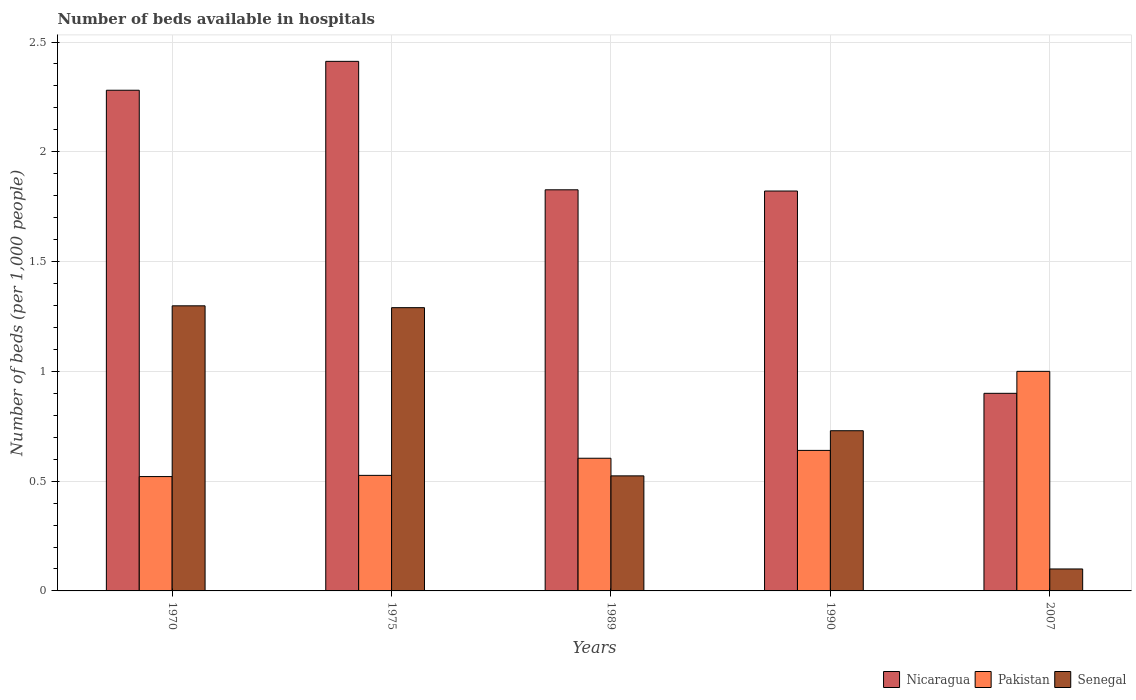How many different coloured bars are there?
Make the answer very short. 3. How many groups of bars are there?
Provide a succinct answer. 5. Are the number of bars per tick equal to the number of legend labels?
Offer a very short reply. Yes. What is the label of the 1st group of bars from the left?
Make the answer very short. 1970. In how many cases, is the number of bars for a given year not equal to the number of legend labels?
Keep it short and to the point. 0. What is the number of beds in the hospiatls of in Pakistan in 1989?
Offer a very short reply. 0.6. Across all years, what is the maximum number of beds in the hospiatls of in Senegal?
Offer a very short reply. 1.3. Across all years, what is the minimum number of beds in the hospiatls of in Senegal?
Provide a short and direct response. 0.1. In which year was the number of beds in the hospiatls of in Nicaragua maximum?
Offer a very short reply. 1975. In which year was the number of beds in the hospiatls of in Nicaragua minimum?
Keep it short and to the point. 2007. What is the total number of beds in the hospiatls of in Nicaragua in the graph?
Your response must be concise. 9.24. What is the difference between the number of beds in the hospiatls of in Pakistan in 1970 and that in 2007?
Offer a very short reply. -0.48. What is the difference between the number of beds in the hospiatls of in Pakistan in 1975 and the number of beds in the hospiatls of in Senegal in 1970?
Provide a succinct answer. -0.77. What is the average number of beds in the hospiatls of in Senegal per year?
Provide a short and direct response. 0.79. In the year 1970, what is the difference between the number of beds in the hospiatls of in Senegal and number of beds in the hospiatls of in Nicaragua?
Give a very brief answer. -0.98. In how many years, is the number of beds in the hospiatls of in Pakistan greater than 2?
Give a very brief answer. 0. What is the ratio of the number of beds in the hospiatls of in Pakistan in 1970 to that in 1989?
Keep it short and to the point. 0.86. Is the number of beds in the hospiatls of in Senegal in 1970 less than that in 1990?
Offer a terse response. No. What is the difference between the highest and the second highest number of beds in the hospiatls of in Pakistan?
Give a very brief answer. 0.36. What is the difference between the highest and the lowest number of beds in the hospiatls of in Senegal?
Give a very brief answer. 1.2. In how many years, is the number of beds in the hospiatls of in Senegal greater than the average number of beds in the hospiatls of in Senegal taken over all years?
Give a very brief answer. 2. What does the 1st bar from the left in 1970 represents?
Offer a very short reply. Nicaragua. What does the 2nd bar from the right in 2007 represents?
Your response must be concise. Pakistan. Is it the case that in every year, the sum of the number of beds in the hospiatls of in Pakistan and number of beds in the hospiatls of in Senegal is greater than the number of beds in the hospiatls of in Nicaragua?
Provide a succinct answer. No. Are all the bars in the graph horizontal?
Your answer should be compact. No. How many years are there in the graph?
Give a very brief answer. 5. Does the graph contain grids?
Offer a very short reply. Yes. How are the legend labels stacked?
Your answer should be compact. Horizontal. What is the title of the graph?
Your answer should be compact. Number of beds available in hospitals. Does "Europe(all income levels)" appear as one of the legend labels in the graph?
Provide a succinct answer. No. What is the label or title of the X-axis?
Your answer should be compact. Years. What is the label or title of the Y-axis?
Your answer should be very brief. Number of beds (per 1,0 people). What is the Number of beds (per 1,000 people) in Nicaragua in 1970?
Your answer should be very brief. 2.28. What is the Number of beds (per 1,000 people) in Pakistan in 1970?
Give a very brief answer. 0.52. What is the Number of beds (per 1,000 people) of Senegal in 1970?
Provide a succinct answer. 1.3. What is the Number of beds (per 1,000 people) of Nicaragua in 1975?
Your answer should be compact. 2.41. What is the Number of beds (per 1,000 people) of Pakistan in 1975?
Ensure brevity in your answer.  0.53. What is the Number of beds (per 1,000 people) of Senegal in 1975?
Provide a short and direct response. 1.29. What is the Number of beds (per 1,000 people) of Nicaragua in 1989?
Provide a short and direct response. 1.83. What is the Number of beds (per 1,000 people) in Pakistan in 1989?
Give a very brief answer. 0.6. What is the Number of beds (per 1,000 people) of Senegal in 1989?
Make the answer very short. 0.52. What is the Number of beds (per 1,000 people) in Nicaragua in 1990?
Give a very brief answer. 1.82. What is the Number of beds (per 1,000 people) of Pakistan in 1990?
Ensure brevity in your answer.  0.64. What is the Number of beds (per 1,000 people) of Senegal in 1990?
Your answer should be compact. 0.73. What is the Number of beds (per 1,000 people) in Nicaragua in 2007?
Offer a very short reply. 0.9. What is the Number of beds (per 1,000 people) of Pakistan in 2007?
Provide a succinct answer. 1. What is the Number of beds (per 1,000 people) of Senegal in 2007?
Keep it short and to the point. 0.1. Across all years, what is the maximum Number of beds (per 1,000 people) of Nicaragua?
Provide a short and direct response. 2.41. Across all years, what is the maximum Number of beds (per 1,000 people) in Senegal?
Ensure brevity in your answer.  1.3. Across all years, what is the minimum Number of beds (per 1,000 people) of Pakistan?
Your response must be concise. 0.52. Across all years, what is the minimum Number of beds (per 1,000 people) in Senegal?
Make the answer very short. 0.1. What is the total Number of beds (per 1,000 people) in Nicaragua in the graph?
Your answer should be compact. 9.24. What is the total Number of beds (per 1,000 people) in Pakistan in the graph?
Your answer should be very brief. 3.29. What is the total Number of beds (per 1,000 people) of Senegal in the graph?
Offer a very short reply. 3.94. What is the difference between the Number of beds (per 1,000 people) of Nicaragua in 1970 and that in 1975?
Provide a short and direct response. -0.13. What is the difference between the Number of beds (per 1,000 people) of Pakistan in 1970 and that in 1975?
Provide a short and direct response. -0.01. What is the difference between the Number of beds (per 1,000 people) of Senegal in 1970 and that in 1975?
Provide a succinct answer. 0.01. What is the difference between the Number of beds (per 1,000 people) of Nicaragua in 1970 and that in 1989?
Offer a very short reply. 0.45. What is the difference between the Number of beds (per 1,000 people) of Pakistan in 1970 and that in 1989?
Provide a short and direct response. -0.08. What is the difference between the Number of beds (per 1,000 people) of Senegal in 1970 and that in 1989?
Your answer should be compact. 0.77. What is the difference between the Number of beds (per 1,000 people) of Nicaragua in 1970 and that in 1990?
Provide a succinct answer. 0.46. What is the difference between the Number of beds (per 1,000 people) of Pakistan in 1970 and that in 1990?
Your answer should be compact. -0.12. What is the difference between the Number of beds (per 1,000 people) of Senegal in 1970 and that in 1990?
Offer a terse response. 0.57. What is the difference between the Number of beds (per 1,000 people) of Nicaragua in 1970 and that in 2007?
Offer a very short reply. 1.38. What is the difference between the Number of beds (per 1,000 people) in Pakistan in 1970 and that in 2007?
Make the answer very short. -0.48. What is the difference between the Number of beds (per 1,000 people) of Senegal in 1970 and that in 2007?
Your answer should be compact. 1.2. What is the difference between the Number of beds (per 1,000 people) in Nicaragua in 1975 and that in 1989?
Your answer should be compact. 0.58. What is the difference between the Number of beds (per 1,000 people) in Pakistan in 1975 and that in 1989?
Your response must be concise. -0.08. What is the difference between the Number of beds (per 1,000 people) of Senegal in 1975 and that in 1989?
Offer a very short reply. 0.77. What is the difference between the Number of beds (per 1,000 people) of Nicaragua in 1975 and that in 1990?
Offer a very short reply. 0.59. What is the difference between the Number of beds (per 1,000 people) in Pakistan in 1975 and that in 1990?
Make the answer very short. -0.11. What is the difference between the Number of beds (per 1,000 people) of Senegal in 1975 and that in 1990?
Your answer should be compact. 0.56. What is the difference between the Number of beds (per 1,000 people) of Nicaragua in 1975 and that in 2007?
Your answer should be very brief. 1.51. What is the difference between the Number of beds (per 1,000 people) in Pakistan in 1975 and that in 2007?
Offer a very short reply. -0.47. What is the difference between the Number of beds (per 1,000 people) in Senegal in 1975 and that in 2007?
Your answer should be compact. 1.19. What is the difference between the Number of beds (per 1,000 people) in Nicaragua in 1989 and that in 1990?
Provide a succinct answer. 0.01. What is the difference between the Number of beds (per 1,000 people) of Pakistan in 1989 and that in 1990?
Offer a terse response. -0.04. What is the difference between the Number of beds (per 1,000 people) of Senegal in 1989 and that in 1990?
Provide a short and direct response. -0.21. What is the difference between the Number of beds (per 1,000 people) of Nicaragua in 1989 and that in 2007?
Offer a terse response. 0.93. What is the difference between the Number of beds (per 1,000 people) in Pakistan in 1989 and that in 2007?
Give a very brief answer. -0.4. What is the difference between the Number of beds (per 1,000 people) in Senegal in 1989 and that in 2007?
Offer a very short reply. 0.42. What is the difference between the Number of beds (per 1,000 people) of Nicaragua in 1990 and that in 2007?
Provide a short and direct response. 0.92. What is the difference between the Number of beds (per 1,000 people) in Pakistan in 1990 and that in 2007?
Ensure brevity in your answer.  -0.36. What is the difference between the Number of beds (per 1,000 people) of Senegal in 1990 and that in 2007?
Provide a succinct answer. 0.63. What is the difference between the Number of beds (per 1,000 people) in Nicaragua in 1970 and the Number of beds (per 1,000 people) in Pakistan in 1975?
Your response must be concise. 1.75. What is the difference between the Number of beds (per 1,000 people) of Nicaragua in 1970 and the Number of beds (per 1,000 people) of Senegal in 1975?
Your response must be concise. 0.99. What is the difference between the Number of beds (per 1,000 people) in Pakistan in 1970 and the Number of beds (per 1,000 people) in Senegal in 1975?
Your response must be concise. -0.77. What is the difference between the Number of beds (per 1,000 people) in Nicaragua in 1970 and the Number of beds (per 1,000 people) in Pakistan in 1989?
Provide a short and direct response. 1.68. What is the difference between the Number of beds (per 1,000 people) of Nicaragua in 1970 and the Number of beds (per 1,000 people) of Senegal in 1989?
Offer a very short reply. 1.76. What is the difference between the Number of beds (per 1,000 people) of Pakistan in 1970 and the Number of beds (per 1,000 people) of Senegal in 1989?
Provide a short and direct response. -0. What is the difference between the Number of beds (per 1,000 people) of Nicaragua in 1970 and the Number of beds (per 1,000 people) of Pakistan in 1990?
Give a very brief answer. 1.64. What is the difference between the Number of beds (per 1,000 people) of Nicaragua in 1970 and the Number of beds (per 1,000 people) of Senegal in 1990?
Give a very brief answer. 1.55. What is the difference between the Number of beds (per 1,000 people) of Pakistan in 1970 and the Number of beds (per 1,000 people) of Senegal in 1990?
Provide a short and direct response. -0.21. What is the difference between the Number of beds (per 1,000 people) in Nicaragua in 1970 and the Number of beds (per 1,000 people) in Pakistan in 2007?
Your answer should be compact. 1.28. What is the difference between the Number of beds (per 1,000 people) of Nicaragua in 1970 and the Number of beds (per 1,000 people) of Senegal in 2007?
Offer a terse response. 2.18. What is the difference between the Number of beds (per 1,000 people) in Pakistan in 1970 and the Number of beds (per 1,000 people) in Senegal in 2007?
Your response must be concise. 0.42. What is the difference between the Number of beds (per 1,000 people) in Nicaragua in 1975 and the Number of beds (per 1,000 people) in Pakistan in 1989?
Your answer should be very brief. 1.81. What is the difference between the Number of beds (per 1,000 people) in Nicaragua in 1975 and the Number of beds (per 1,000 people) in Senegal in 1989?
Offer a terse response. 1.89. What is the difference between the Number of beds (per 1,000 people) of Pakistan in 1975 and the Number of beds (per 1,000 people) of Senegal in 1989?
Provide a short and direct response. 0. What is the difference between the Number of beds (per 1,000 people) of Nicaragua in 1975 and the Number of beds (per 1,000 people) of Pakistan in 1990?
Your answer should be compact. 1.77. What is the difference between the Number of beds (per 1,000 people) in Nicaragua in 1975 and the Number of beds (per 1,000 people) in Senegal in 1990?
Offer a terse response. 1.68. What is the difference between the Number of beds (per 1,000 people) in Pakistan in 1975 and the Number of beds (per 1,000 people) in Senegal in 1990?
Make the answer very short. -0.2. What is the difference between the Number of beds (per 1,000 people) of Nicaragua in 1975 and the Number of beds (per 1,000 people) of Pakistan in 2007?
Make the answer very short. 1.41. What is the difference between the Number of beds (per 1,000 people) of Nicaragua in 1975 and the Number of beds (per 1,000 people) of Senegal in 2007?
Offer a very short reply. 2.31. What is the difference between the Number of beds (per 1,000 people) of Pakistan in 1975 and the Number of beds (per 1,000 people) of Senegal in 2007?
Your response must be concise. 0.43. What is the difference between the Number of beds (per 1,000 people) of Nicaragua in 1989 and the Number of beds (per 1,000 people) of Pakistan in 1990?
Keep it short and to the point. 1.19. What is the difference between the Number of beds (per 1,000 people) in Nicaragua in 1989 and the Number of beds (per 1,000 people) in Senegal in 1990?
Give a very brief answer. 1.1. What is the difference between the Number of beds (per 1,000 people) of Pakistan in 1989 and the Number of beds (per 1,000 people) of Senegal in 1990?
Make the answer very short. -0.13. What is the difference between the Number of beds (per 1,000 people) of Nicaragua in 1989 and the Number of beds (per 1,000 people) of Pakistan in 2007?
Your response must be concise. 0.83. What is the difference between the Number of beds (per 1,000 people) in Nicaragua in 1989 and the Number of beds (per 1,000 people) in Senegal in 2007?
Your response must be concise. 1.73. What is the difference between the Number of beds (per 1,000 people) in Pakistan in 1989 and the Number of beds (per 1,000 people) in Senegal in 2007?
Keep it short and to the point. 0.5. What is the difference between the Number of beds (per 1,000 people) of Nicaragua in 1990 and the Number of beds (per 1,000 people) of Pakistan in 2007?
Provide a succinct answer. 0.82. What is the difference between the Number of beds (per 1,000 people) in Nicaragua in 1990 and the Number of beds (per 1,000 people) in Senegal in 2007?
Make the answer very short. 1.72. What is the difference between the Number of beds (per 1,000 people) in Pakistan in 1990 and the Number of beds (per 1,000 people) in Senegal in 2007?
Make the answer very short. 0.54. What is the average Number of beds (per 1,000 people) in Nicaragua per year?
Provide a short and direct response. 1.85. What is the average Number of beds (per 1,000 people) of Pakistan per year?
Offer a terse response. 0.66. What is the average Number of beds (per 1,000 people) in Senegal per year?
Offer a very short reply. 0.79. In the year 1970, what is the difference between the Number of beds (per 1,000 people) in Nicaragua and Number of beds (per 1,000 people) in Pakistan?
Provide a short and direct response. 1.76. In the year 1970, what is the difference between the Number of beds (per 1,000 people) of Nicaragua and Number of beds (per 1,000 people) of Senegal?
Give a very brief answer. 0.98. In the year 1970, what is the difference between the Number of beds (per 1,000 people) in Pakistan and Number of beds (per 1,000 people) in Senegal?
Your answer should be compact. -0.78. In the year 1975, what is the difference between the Number of beds (per 1,000 people) in Nicaragua and Number of beds (per 1,000 people) in Pakistan?
Offer a very short reply. 1.89. In the year 1975, what is the difference between the Number of beds (per 1,000 people) in Nicaragua and Number of beds (per 1,000 people) in Senegal?
Offer a terse response. 1.12. In the year 1975, what is the difference between the Number of beds (per 1,000 people) of Pakistan and Number of beds (per 1,000 people) of Senegal?
Give a very brief answer. -0.76. In the year 1989, what is the difference between the Number of beds (per 1,000 people) in Nicaragua and Number of beds (per 1,000 people) in Pakistan?
Make the answer very short. 1.22. In the year 1989, what is the difference between the Number of beds (per 1,000 people) in Nicaragua and Number of beds (per 1,000 people) in Senegal?
Give a very brief answer. 1.3. In the year 1989, what is the difference between the Number of beds (per 1,000 people) in Pakistan and Number of beds (per 1,000 people) in Senegal?
Offer a very short reply. 0.08. In the year 1990, what is the difference between the Number of beds (per 1,000 people) of Nicaragua and Number of beds (per 1,000 people) of Pakistan?
Provide a succinct answer. 1.18. In the year 1990, what is the difference between the Number of beds (per 1,000 people) in Nicaragua and Number of beds (per 1,000 people) in Senegal?
Ensure brevity in your answer.  1.09. In the year 1990, what is the difference between the Number of beds (per 1,000 people) in Pakistan and Number of beds (per 1,000 people) in Senegal?
Provide a short and direct response. -0.09. In the year 2007, what is the difference between the Number of beds (per 1,000 people) in Nicaragua and Number of beds (per 1,000 people) in Pakistan?
Keep it short and to the point. -0.1. In the year 2007, what is the difference between the Number of beds (per 1,000 people) of Nicaragua and Number of beds (per 1,000 people) of Senegal?
Keep it short and to the point. 0.8. What is the ratio of the Number of beds (per 1,000 people) of Nicaragua in 1970 to that in 1975?
Your answer should be compact. 0.95. What is the ratio of the Number of beds (per 1,000 people) in Senegal in 1970 to that in 1975?
Offer a terse response. 1.01. What is the ratio of the Number of beds (per 1,000 people) in Nicaragua in 1970 to that in 1989?
Provide a short and direct response. 1.25. What is the ratio of the Number of beds (per 1,000 people) in Pakistan in 1970 to that in 1989?
Ensure brevity in your answer.  0.86. What is the ratio of the Number of beds (per 1,000 people) in Senegal in 1970 to that in 1989?
Ensure brevity in your answer.  2.48. What is the ratio of the Number of beds (per 1,000 people) in Nicaragua in 1970 to that in 1990?
Your answer should be very brief. 1.25. What is the ratio of the Number of beds (per 1,000 people) of Pakistan in 1970 to that in 1990?
Provide a succinct answer. 0.81. What is the ratio of the Number of beds (per 1,000 people) of Senegal in 1970 to that in 1990?
Offer a terse response. 1.78. What is the ratio of the Number of beds (per 1,000 people) in Nicaragua in 1970 to that in 2007?
Make the answer very short. 2.53. What is the ratio of the Number of beds (per 1,000 people) of Pakistan in 1970 to that in 2007?
Provide a succinct answer. 0.52. What is the ratio of the Number of beds (per 1,000 people) in Senegal in 1970 to that in 2007?
Make the answer very short. 12.98. What is the ratio of the Number of beds (per 1,000 people) of Nicaragua in 1975 to that in 1989?
Your answer should be compact. 1.32. What is the ratio of the Number of beds (per 1,000 people) in Pakistan in 1975 to that in 1989?
Provide a short and direct response. 0.87. What is the ratio of the Number of beds (per 1,000 people) in Senegal in 1975 to that in 1989?
Offer a terse response. 2.46. What is the ratio of the Number of beds (per 1,000 people) in Nicaragua in 1975 to that in 1990?
Give a very brief answer. 1.32. What is the ratio of the Number of beds (per 1,000 people) in Pakistan in 1975 to that in 1990?
Provide a succinct answer. 0.82. What is the ratio of the Number of beds (per 1,000 people) in Senegal in 1975 to that in 1990?
Your answer should be compact. 1.77. What is the ratio of the Number of beds (per 1,000 people) in Nicaragua in 1975 to that in 2007?
Give a very brief answer. 2.68. What is the ratio of the Number of beds (per 1,000 people) of Pakistan in 1975 to that in 2007?
Keep it short and to the point. 0.53. What is the ratio of the Number of beds (per 1,000 people) of Senegal in 1975 to that in 2007?
Provide a succinct answer. 12.9. What is the ratio of the Number of beds (per 1,000 people) in Nicaragua in 1989 to that in 1990?
Offer a very short reply. 1. What is the ratio of the Number of beds (per 1,000 people) of Pakistan in 1989 to that in 1990?
Give a very brief answer. 0.94. What is the ratio of the Number of beds (per 1,000 people) of Senegal in 1989 to that in 1990?
Provide a succinct answer. 0.72. What is the ratio of the Number of beds (per 1,000 people) in Nicaragua in 1989 to that in 2007?
Offer a very short reply. 2.03. What is the ratio of the Number of beds (per 1,000 people) in Pakistan in 1989 to that in 2007?
Give a very brief answer. 0.6. What is the ratio of the Number of beds (per 1,000 people) in Senegal in 1989 to that in 2007?
Provide a succinct answer. 5.24. What is the ratio of the Number of beds (per 1,000 people) in Nicaragua in 1990 to that in 2007?
Give a very brief answer. 2.02. What is the ratio of the Number of beds (per 1,000 people) in Pakistan in 1990 to that in 2007?
Your answer should be compact. 0.64. What is the ratio of the Number of beds (per 1,000 people) of Senegal in 1990 to that in 2007?
Ensure brevity in your answer.  7.3. What is the difference between the highest and the second highest Number of beds (per 1,000 people) in Nicaragua?
Provide a succinct answer. 0.13. What is the difference between the highest and the second highest Number of beds (per 1,000 people) in Pakistan?
Your response must be concise. 0.36. What is the difference between the highest and the second highest Number of beds (per 1,000 people) in Senegal?
Provide a succinct answer. 0.01. What is the difference between the highest and the lowest Number of beds (per 1,000 people) in Nicaragua?
Provide a short and direct response. 1.51. What is the difference between the highest and the lowest Number of beds (per 1,000 people) in Pakistan?
Provide a short and direct response. 0.48. What is the difference between the highest and the lowest Number of beds (per 1,000 people) of Senegal?
Your response must be concise. 1.2. 